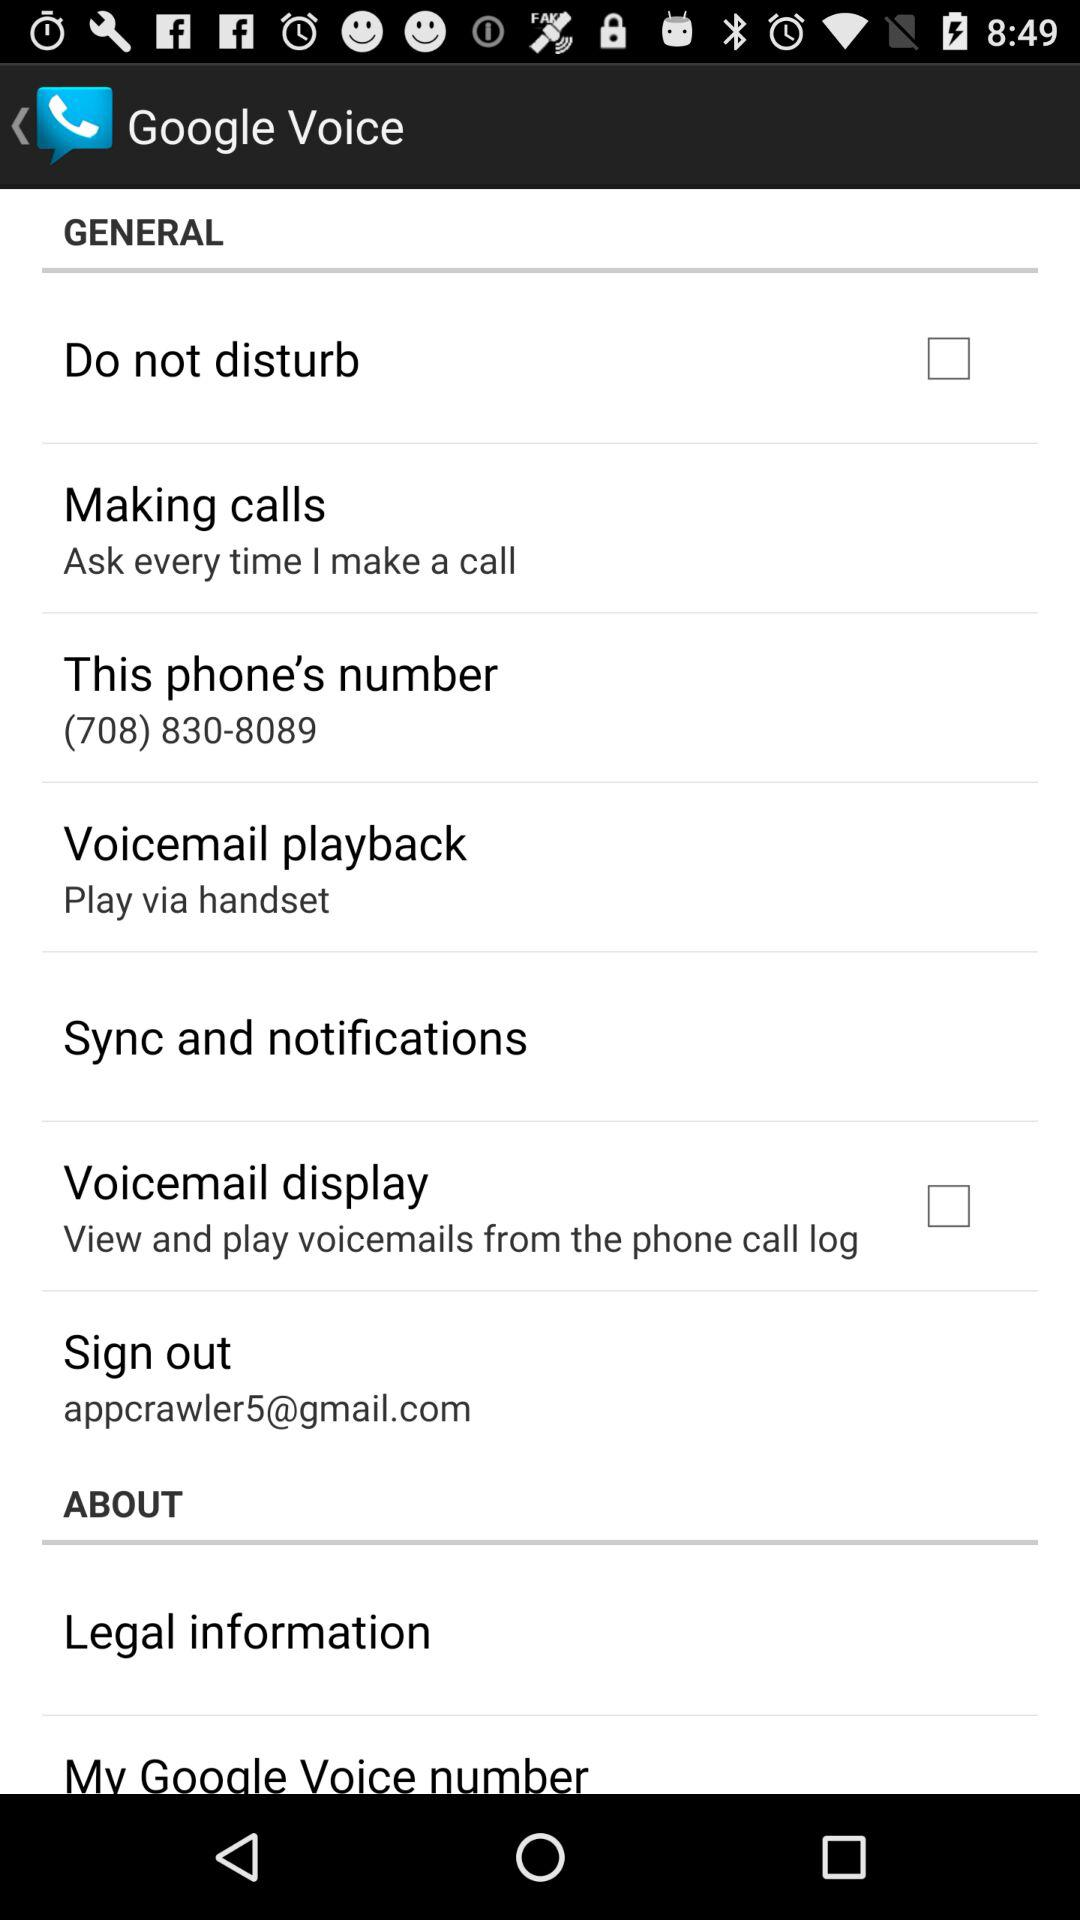What is the status of "Do not disturb"? The status is "off". 